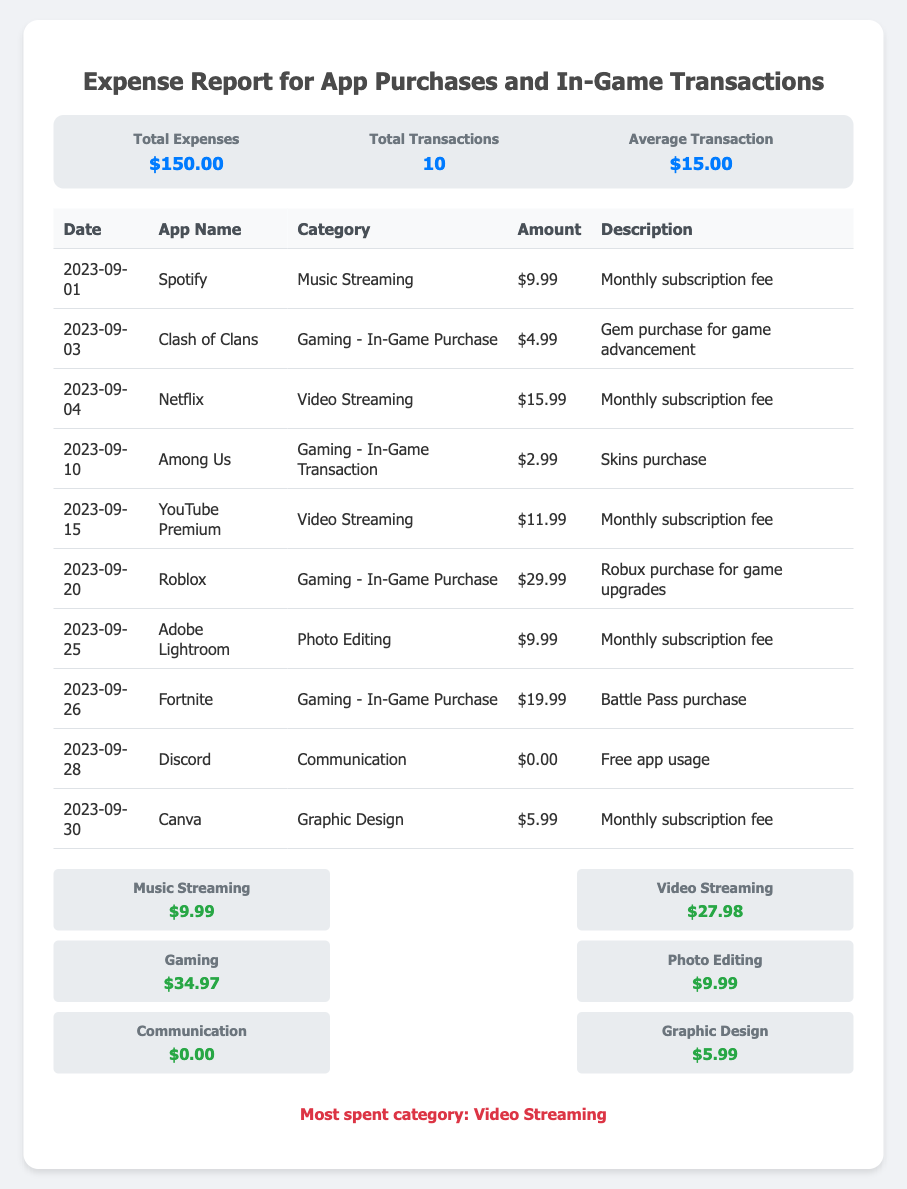What is the total amount spent? The total amount spent is listed in the summary section of the document, which is $150.00.
Answer: $150.00 How many total transactions were made? The total transactions are indicated in the summary section of the document, which states there were 10 transactions.
Answer: 10 What is the average transaction amount? The average transaction amount is provided in the summary section, which shows $15.00.
Answer: $15.00 Which category had the highest expense? The document highlights "Video Streaming" as the most spent category in the category analysis section.
Answer: Video Streaming What was the date of the Fortnite purchase? The date of the Fortnite purchase is mentioned in the table of transactions as September 26, 2023.
Answer: 2023-09-26 How much was spent on Roblox? The amount spent on Roblox is listed in the transactions table as $29.99.
Answer: $29.99 What is the total amount spent on music streaming? The document shows that the total spent on music streaming was $9.99 in the category analysis section.
Answer: $9.99 How many gaming in-game purchases were made? The document lists three gaming in-game purchases in the transaction table for Clash of Clans, Among Us, and Fortnite.
Answer: 3 What is the description for the Canva expense? The description for the Canva expense is provided in the transactions table, stating it is for the "Monthly subscription fee."
Answer: Monthly subscription fee 